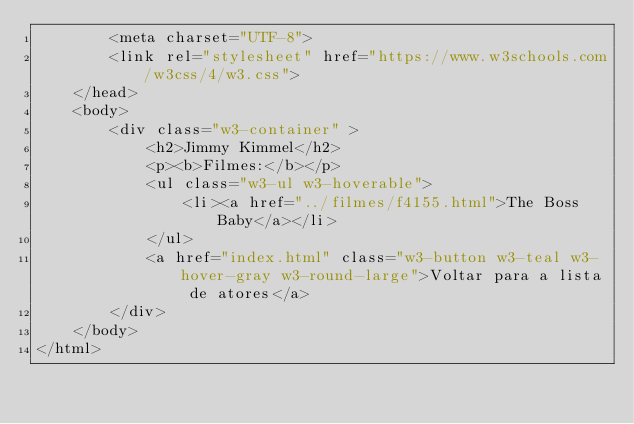<code> <loc_0><loc_0><loc_500><loc_500><_HTML_>        <meta charset="UTF-8">
        <link rel="stylesheet" href="https://www.w3schools.com/w3css/4/w3.css">
    </head>
    <body>
        <div class="w3-container" >
            <h2>Jimmy Kimmel</h2>
            <p><b>Filmes:</b></p>
            <ul class="w3-ul w3-hoverable">
				<li><a href="../filmes/f4155.html">The Boss Baby</a></li>
			</ul>
            <a href="index.html" class="w3-button w3-teal w3-hover-gray w3-round-large">Voltar para a lista de atores</a>
        </div>
    </body>
</html></code> 